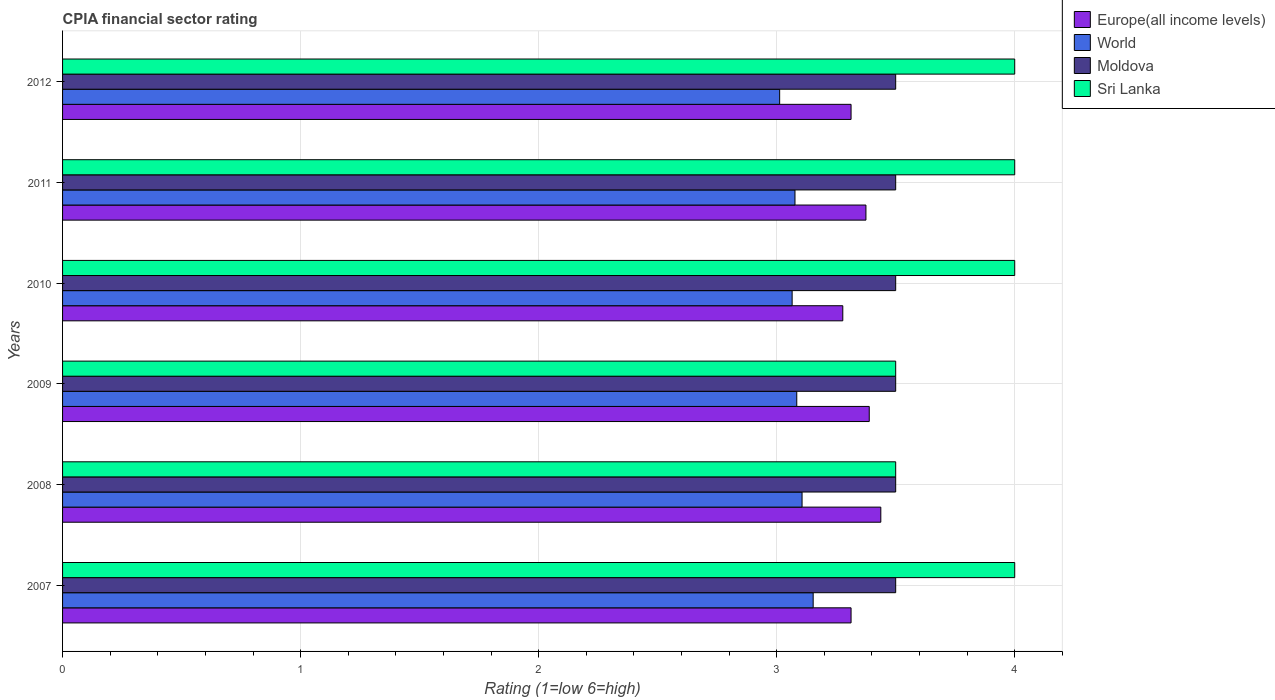How many different coloured bars are there?
Provide a short and direct response. 4. How many groups of bars are there?
Keep it short and to the point. 6. Are the number of bars on each tick of the Y-axis equal?
Offer a terse response. Yes. What is the label of the 4th group of bars from the top?
Give a very brief answer. 2009. What is the CPIA rating in Europe(all income levels) in 2010?
Your answer should be very brief. 3.28. Across all years, what is the maximum CPIA rating in Europe(all income levels)?
Give a very brief answer. 3.44. Across all years, what is the minimum CPIA rating in Europe(all income levels)?
Keep it short and to the point. 3.28. In which year was the CPIA rating in Sri Lanka maximum?
Make the answer very short. 2007. In which year was the CPIA rating in Moldova minimum?
Ensure brevity in your answer.  2007. What is the total CPIA rating in Sri Lanka in the graph?
Offer a terse response. 23. What is the difference between the CPIA rating in Moldova in 2007 and that in 2008?
Provide a succinct answer. 0. What is the difference between the CPIA rating in World in 2010 and the CPIA rating in Sri Lanka in 2011?
Offer a very short reply. -0.94. What is the average CPIA rating in Moldova per year?
Offer a very short reply. 3.5. In the year 2007, what is the difference between the CPIA rating in Sri Lanka and CPIA rating in Moldova?
Ensure brevity in your answer.  0.5. What is the ratio of the CPIA rating in Moldova in 2009 to that in 2010?
Offer a terse response. 1. Is the CPIA rating in Europe(all income levels) in 2010 less than that in 2012?
Offer a very short reply. Yes. Is the difference between the CPIA rating in Sri Lanka in 2007 and 2011 greater than the difference between the CPIA rating in Moldova in 2007 and 2011?
Offer a terse response. No. What is the difference between the highest and the lowest CPIA rating in World?
Provide a short and direct response. 0.14. Is the sum of the CPIA rating in Sri Lanka in 2007 and 2008 greater than the maximum CPIA rating in Moldova across all years?
Offer a terse response. Yes. Is it the case that in every year, the sum of the CPIA rating in Sri Lanka and CPIA rating in Moldova is greater than the sum of CPIA rating in Europe(all income levels) and CPIA rating in World?
Provide a succinct answer. No. What does the 4th bar from the top in 2011 represents?
Keep it short and to the point. Europe(all income levels). What does the 1st bar from the bottom in 2011 represents?
Offer a very short reply. Europe(all income levels). Is it the case that in every year, the sum of the CPIA rating in Moldova and CPIA rating in World is greater than the CPIA rating in Europe(all income levels)?
Your answer should be compact. Yes. What is the difference between two consecutive major ticks on the X-axis?
Give a very brief answer. 1. Does the graph contain any zero values?
Your response must be concise. No. What is the title of the graph?
Keep it short and to the point. CPIA financial sector rating. Does "Suriname" appear as one of the legend labels in the graph?
Your answer should be very brief. No. What is the label or title of the X-axis?
Provide a short and direct response. Rating (1=low 6=high). What is the label or title of the Y-axis?
Give a very brief answer. Years. What is the Rating (1=low 6=high) of Europe(all income levels) in 2007?
Offer a terse response. 3.31. What is the Rating (1=low 6=high) of World in 2007?
Keep it short and to the point. 3.15. What is the Rating (1=low 6=high) of Europe(all income levels) in 2008?
Offer a very short reply. 3.44. What is the Rating (1=low 6=high) of World in 2008?
Offer a terse response. 3.11. What is the Rating (1=low 6=high) in Moldova in 2008?
Offer a terse response. 3.5. What is the Rating (1=low 6=high) of Sri Lanka in 2008?
Make the answer very short. 3.5. What is the Rating (1=low 6=high) in Europe(all income levels) in 2009?
Offer a very short reply. 3.39. What is the Rating (1=low 6=high) of World in 2009?
Offer a very short reply. 3.08. What is the Rating (1=low 6=high) of Moldova in 2009?
Ensure brevity in your answer.  3.5. What is the Rating (1=low 6=high) in Sri Lanka in 2009?
Make the answer very short. 3.5. What is the Rating (1=low 6=high) of Europe(all income levels) in 2010?
Your answer should be compact. 3.28. What is the Rating (1=low 6=high) in World in 2010?
Keep it short and to the point. 3.06. What is the Rating (1=low 6=high) in Moldova in 2010?
Your response must be concise. 3.5. What is the Rating (1=low 6=high) in Sri Lanka in 2010?
Provide a short and direct response. 4. What is the Rating (1=low 6=high) of Europe(all income levels) in 2011?
Make the answer very short. 3.38. What is the Rating (1=low 6=high) of World in 2011?
Ensure brevity in your answer.  3.08. What is the Rating (1=low 6=high) in Moldova in 2011?
Your answer should be compact. 3.5. What is the Rating (1=low 6=high) in Europe(all income levels) in 2012?
Give a very brief answer. 3.31. What is the Rating (1=low 6=high) in World in 2012?
Ensure brevity in your answer.  3.01. What is the Rating (1=low 6=high) of Moldova in 2012?
Offer a very short reply. 3.5. Across all years, what is the maximum Rating (1=low 6=high) in Europe(all income levels)?
Ensure brevity in your answer.  3.44. Across all years, what is the maximum Rating (1=low 6=high) of World?
Give a very brief answer. 3.15. Across all years, what is the maximum Rating (1=low 6=high) in Moldova?
Offer a very short reply. 3.5. Across all years, what is the minimum Rating (1=low 6=high) in Europe(all income levels)?
Your answer should be compact. 3.28. Across all years, what is the minimum Rating (1=low 6=high) in World?
Your answer should be very brief. 3.01. Across all years, what is the minimum Rating (1=low 6=high) of Moldova?
Offer a terse response. 3.5. Across all years, what is the minimum Rating (1=low 6=high) of Sri Lanka?
Make the answer very short. 3.5. What is the total Rating (1=low 6=high) in Europe(all income levels) in the graph?
Keep it short and to the point. 20.1. What is the total Rating (1=low 6=high) of World in the graph?
Make the answer very short. 18.5. What is the total Rating (1=low 6=high) in Moldova in the graph?
Your answer should be very brief. 21. What is the total Rating (1=low 6=high) in Sri Lanka in the graph?
Provide a short and direct response. 23. What is the difference between the Rating (1=low 6=high) in Europe(all income levels) in 2007 and that in 2008?
Offer a very short reply. -0.12. What is the difference between the Rating (1=low 6=high) of World in 2007 and that in 2008?
Offer a terse response. 0.05. What is the difference between the Rating (1=low 6=high) in Moldova in 2007 and that in 2008?
Keep it short and to the point. 0. What is the difference between the Rating (1=low 6=high) in Europe(all income levels) in 2007 and that in 2009?
Make the answer very short. -0.08. What is the difference between the Rating (1=low 6=high) of World in 2007 and that in 2009?
Make the answer very short. 0.07. What is the difference between the Rating (1=low 6=high) of Sri Lanka in 2007 and that in 2009?
Give a very brief answer. 0.5. What is the difference between the Rating (1=low 6=high) of Europe(all income levels) in 2007 and that in 2010?
Give a very brief answer. 0.03. What is the difference between the Rating (1=low 6=high) of World in 2007 and that in 2010?
Ensure brevity in your answer.  0.09. What is the difference between the Rating (1=low 6=high) in Europe(all income levels) in 2007 and that in 2011?
Provide a short and direct response. -0.06. What is the difference between the Rating (1=low 6=high) of World in 2007 and that in 2011?
Provide a short and direct response. 0.08. What is the difference between the Rating (1=low 6=high) of Moldova in 2007 and that in 2011?
Your response must be concise. 0. What is the difference between the Rating (1=low 6=high) of World in 2007 and that in 2012?
Offer a terse response. 0.14. What is the difference between the Rating (1=low 6=high) of Europe(all income levels) in 2008 and that in 2009?
Your answer should be compact. 0.05. What is the difference between the Rating (1=low 6=high) in World in 2008 and that in 2009?
Provide a succinct answer. 0.02. What is the difference between the Rating (1=low 6=high) in Moldova in 2008 and that in 2009?
Offer a terse response. 0. What is the difference between the Rating (1=low 6=high) of Europe(all income levels) in 2008 and that in 2010?
Make the answer very short. 0.16. What is the difference between the Rating (1=low 6=high) of World in 2008 and that in 2010?
Offer a very short reply. 0.04. What is the difference between the Rating (1=low 6=high) of Moldova in 2008 and that in 2010?
Offer a terse response. 0. What is the difference between the Rating (1=low 6=high) of Sri Lanka in 2008 and that in 2010?
Provide a short and direct response. -0.5. What is the difference between the Rating (1=low 6=high) of Europe(all income levels) in 2008 and that in 2011?
Provide a short and direct response. 0.06. What is the difference between the Rating (1=low 6=high) of World in 2008 and that in 2011?
Offer a terse response. 0.03. What is the difference between the Rating (1=low 6=high) of Moldova in 2008 and that in 2011?
Your response must be concise. 0. What is the difference between the Rating (1=low 6=high) of Sri Lanka in 2008 and that in 2011?
Ensure brevity in your answer.  -0.5. What is the difference between the Rating (1=low 6=high) in Europe(all income levels) in 2008 and that in 2012?
Your answer should be very brief. 0.12. What is the difference between the Rating (1=low 6=high) of World in 2008 and that in 2012?
Offer a terse response. 0.09. What is the difference between the Rating (1=low 6=high) of Sri Lanka in 2008 and that in 2012?
Provide a short and direct response. -0.5. What is the difference between the Rating (1=low 6=high) in Europe(all income levels) in 2009 and that in 2010?
Keep it short and to the point. 0.11. What is the difference between the Rating (1=low 6=high) in World in 2009 and that in 2010?
Your answer should be compact. 0.02. What is the difference between the Rating (1=low 6=high) in Moldova in 2009 and that in 2010?
Your response must be concise. 0. What is the difference between the Rating (1=low 6=high) of Sri Lanka in 2009 and that in 2010?
Provide a short and direct response. -0.5. What is the difference between the Rating (1=low 6=high) of Europe(all income levels) in 2009 and that in 2011?
Your response must be concise. 0.01. What is the difference between the Rating (1=low 6=high) of World in 2009 and that in 2011?
Provide a short and direct response. 0.01. What is the difference between the Rating (1=low 6=high) in Europe(all income levels) in 2009 and that in 2012?
Offer a very short reply. 0.08. What is the difference between the Rating (1=low 6=high) of World in 2009 and that in 2012?
Offer a terse response. 0.07. What is the difference between the Rating (1=low 6=high) in Moldova in 2009 and that in 2012?
Your answer should be very brief. 0. What is the difference between the Rating (1=low 6=high) in Europe(all income levels) in 2010 and that in 2011?
Give a very brief answer. -0.1. What is the difference between the Rating (1=low 6=high) in World in 2010 and that in 2011?
Your answer should be compact. -0.01. What is the difference between the Rating (1=low 6=high) of Moldova in 2010 and that in 2011?
Your response must be concise. 0. What is the difference between the Rating (1=low 6=high) in Sri Lanka in 2010 and that in 2011?
Make the answer very short. 0. What is the difference between the Rating (1=low 6=high) in Europe(all income levels) in 2010 and that in 2012?
Offer a very short reply. -0.03. What is the difference between the Rating (1=low 6=high) in World in 2010 and that in 2012?
Provide a short and direct response. 0.05. What is the difference between the Rating (1=low 6=high) in Europe(all income levels) in 2011 and that in 2012?
Your answer should be compact. 0.06. What is the difference between the Rating (1=low 6=high) in World in 2011 and that in 2012?
Make the answer very short. 0.06. What is the difference between the Rating (1=low 6=high) of Europe(all income levels) in 2007 and the Rating (1=low 6=high) of World in 2008?
Your response must be concise. 0.21. What is the difference between the Rating (1=low 6=high) in Europe(all income levels) in 2007 and the Rating (1=low 6=high) in Moldova in 2008?
Your answer should be very brief. -0.19. What is the difference between the Rating (1=low 6=high) of Europe(all income levels) in 2007 and the Rating (1=low 6=high) of Sri Lanka in 2008?
Your answer should be very brief. -0.19. What is the difference between the Rating (1=low 6=high) in World in 2007 and the Rating (1=low 6=high) in Moldova in 2008?
Ensure brevity in your answer.  -0.35. What is the difference between the Rating (1=low 6=high) in World in 2007 and the Rating (1=low 6=high) in Sri Lanka in 2008?
Your answer should be very brief. -0.35. What is the difference between the Rating (1=low 6=high) of Europe(all income levels) in 2007 and the Rating (1=low 6=high) of World in 2009?
Offer a terse response. 0.23. What is the difference between the Rating (1=low 6=high) of Europe(all income levels) in 2007 and the Rating (1=low 6=high) of Moldova in 2009?
Your answer should be very brief. -0.19. What is the difference between the Rating (1=low 6=high) in Europe(all income levels) in 2007 and the Rating (1=low 6=high) in Sri Lanka in 2009?
Keep it short and to the point. -0.19. What is the difference between the Rating (1=low 6=high) in World in 2007 and the Rating (1=low 6=high) in Moldova in 2009?
Your response must be concise. -0.35. What is the difference between the Rating (1=low 6=high) of World in 2007 and the Rating (1=low 6=high) of Sri Lanka in 2009?
Your response must be concise. -0.35. What is the difference between the Rating (1=low 6=high) in Europe(all income levels) in 2007 and the Rating (1=low 6=high) in World in 2010?
Your answer should be compact. 0.25. What is the difference between the Rating (1=low 6=high) of Europe(all income levels) in 2007 and the Rating (1=low 6=high) of Moldova in 2010?
Provide a succinct answer. -0.19. What is the difference between the Rating (1=low 6=high) of Europe(all income levels) in 2007 and the Rating (1=low 6=high) of Sri Lanka in 2010?
Provide a succinct answer. -0.69. What is the difference between the Rating (1=low 6=high) in World in 2007 and the Rating (1=low 6=high) in Moldova in 2010?
Offer a very short reply. -0.35. What is the difference between the Rating (1=low 6=high) in World in 2007 and the Rating (1=low 6=high) in Sri Lanka in 2010?
Your answer should be compact. -0.85. What is the difference between the Rating (1=low 6=high) in Moldova in 2007 and the Rating (1=low 6=high) in Sri Lanka in 2010?
Your response must be concise. -0.5. What is the difference between the Rating (1=low 6=high) in Europe(all income levels) in 2007 and the Rating (1=low 6=high) in World in 2011?
Offer a very short reply. 0.24. What is the difference between the Rating (1=low 6=high) of Europe(all income levels) in 2007 and the Rating (1=low 6=high) of Moldova in 2011?
Keep it short and to the point. -0.19. What is the difference between the Rating (1=low 6=high) of Europe(all income levels) in 2007 and the Rating (1=low 6=high) of Sri Lanka in 2011?
Make the answer very short. -0.69. What is the difference between the Rating (1=low 6=high) in World in 2007 and the Rating (1=low 6=high) in Moldova in 2011?
Offer a terse response. -0.35. What is the difference between the Rating (1=low 6=high) in World in 2007 and the Rating (1=low 6=high) in Sri Lanka in 2011?
Your answer should be compact. -0.85. What is the difference between the Rating (1=low 6=high) of Europe(all income levels) in 2007 and the Rating (1=low 6=high) of World in 2012?
Your answer should be very brief. 0.3. What is the difference between the Rating (1=low 6=high) of Europe(all income levels) in 2007 and the Rating (1=low 6=high) of Moldova in 2012?
Keep it short and to the point. -0.19. What is the difference between the Rating (1=low 6=high) in Europe(all income levels) in 2007 and the Rating (1=low 6=high) in Sri Lanka in 2012?
Offer a terse response. -0.69. What is the difference between the Rating (1=low 6=high) of World in 2007 and the Rating (1=low 6=high) of Moldova in 2012?
Provide a short and direct response. -0.35. What is the difference between the Rating (1=low 6=high) of World in 2007 and the Rating (1=low 6=high) of Sri Lanka in 2012?
Keep it short and to the point. -0.85. What is the difference between the Rating (1=low 6=high) of Europe(all income levels) in 2008 and the Rating (1=low 6=high) of World in 2009?
Provide a short and direct response. 0.35. What is the difference between the Rating (1=low 6=high) in Europe(all income levels) in 2008 and the Rating (1=low 6=high) in Moldova in 2009?
Offer a terse response. -0.06. What is the difference between the Rating (1=low 6=high) in Europe(all income levels) in 2008 and the Rating (1=low 6=high) in Sri Lanka in 2009?
Your response must be concise. -0.06. What is the difference between the Rating (1=low 6=high) in World in 2008 and the Rating (1=low 6=high) in Moldova in 2009?
Provide a succinct answer. -0.39. What is the difference between the Rating (1=low 6=high) in World in 2008 and the Rating (1=low 6=high) in Sri Lanka in 2009?
Your answer should be very brief. -0.39. What is the difference between the Rating (1=low 6=high) in Europe(all income levels) in 2008 and the Rating (1=low 6=high) in World in 2010?
Your answer should be very brief. 0.37. What is the difference between the Rating (1=low 6=high) in Europe(all income levels) in 2008 and the Rating (1=low 6=high) in Moldova in 2010?
Your response must be concise. -0.06. What is the difference between the Rating (1=low 6=high) of Europe(all income levels) in 2008 and the Rating (1=low 6=high) of Sri Lanka in 2010?
Your answer should be compact. -0.56. What is the difference between the Rating (1=low 6=high) in World in 2008 and the Rating (1=low 6=high) in Moldova in 2010?
Your answer should be compact. -0.39. What is the difference between the Rating (1=low 6=high) of World in 2008 and the Rating (1=low 6=high) of Sri Lanka in 2010?
Keep it short and to the point. -0.89. What is the difference between the Rating (1=low 6=high) of Moldova in 2008 and the Rating (1=low 6=high) of Sri Lanka in 2010?
Keep it short and to the point. -0.5. What is the difference between the Rating (1=low 6=high) of Europe(all income levels) in 2008 and the Rating (1=low 6=high) of World in 2011?
Your answer should be very brief. 0.36. What is the difference between the Rating (1=low 6=high) in Europe(all income levels) in 2008 and the Rating (1=low 6=high) in Moldova in 2011?
Your answer should be compact. -0.06. What is the difference between the Rating (1=low 6=high) of Europe(all income levels) in 2008 and the Rating (1=low 6=high) of Sri Lanka in 2011?
Offer a terse response. -0.56. What is the difference between the Rating (1=low 6=high) in World in 2008 and the Rating (1=low 6=high) in Moldova in 2011?
Give a very brief answer. -0.39. What is the difference between the Rating (1=low 6=high) of World in 2008 and the Rating (1=low 6=high) of Sri Lanka in 2011?
Make the answer very short. -0.89. What is the difference between the Rating (1=low 6=high) in Moldova in 2008 and the Rating (1=low 6=high) in Sri Lanka in 2011?
Your response must be concise. -0.5. What is the difference between the Rating (1=low 6=high) of Europe(all income levels) in 2008 and the Rating (1=low 6=high) of World in 2012?
Provide a succinct answer. 0.42. What is the difference between the Rating (1=low 6=high) in Europe(all income levels) in 2008 and the Rating (1=low 6=high) in Moldova in 2012?
Keep it short and to the point. -0.06. What is the difference between the Rating (1=low 6=high) of Europe(all income levels) in 2008 and the Rating (1=low 6=high) of Sri Lanka in 2012?
Ensure brevity in your answer.  -0.56. What is the difference between the Rating (1=low 6=high) of World in 2008 and the Rating (1=low 6=high) of Moldova in 2012?
Make the answer very short. -0.39. What is the difference between the Rating (1=low 6=high) of World in 2008 and the Rating (1=low 6=high) of Sri Lanka in 2012?
Ensure brevity in your answer.  -0.89. What is the difference between the Rating (1=low 6=high) of Europe(all income levels) in 2009 and the Rating (1=low 6=high) of World in 2010?
Provide a succinct answer. 0.32. What is the difference between the Rating (1=low 6=high) of Europe(all income levels) in 2009 and the Rating (1=low 6=high) of Moldova in 2010?
Make the answer very short. -0.11. What is the difference between the Rating (1=low 6=high) of Europe(all income levels) in 2009 and the Rating (1=low 6=high) of Sri Lanka in 2010?
Offer a very short reply. -0.61. What is the difference between the Rating (1=low 6=high) of World in 2009 and the Rating (1=low 6=high) of Moldova in 2010?
Offer a very short reply. -0.42. What is the difference between the Rating (1=low 6=high) in World in 2009 and the Rating (1=low 6=high) in Sri Lanka in 2010?
Offer a terse response. -0.92. What is the difference between the Rating (1=low 6=high) of Moldova in 2009 and the Rating (1=low 6=high) of Sri Lanka in 2010?
Your answer should be very brief. -0.5. What is the difference between the Rating (1=low 6=high) of Europe(all income levels) in 2009 and the Rating (1=low 6=high) of World in 2011?
Ensure brevity in your answer.  0.31. What is the difference between the Rating (1=low 6=high) in Europe(all income levels) in 2009 and the Rating (1=low 6=high) in Moldova in 2011?
Your response must be concise. -0.11. What is the difference between the Rating (1=low 6=high) of Europe(all income levels) in 2009 and the Rating (1=low 6=high) of Sri Lanka in 2011?
Your answer should be compact. -0.61. What is the difference between the Rating (1=low 6=high) in World in 2009 and the Rating (1=low 6=high) in Moldova in 2011?
Give a very brief answer. -0.42. What is the difference between the Rating (1=low 6=high) of World in 2009 and the Rating (1=low 6=high) of Sri Lanka in 2011?
Offer a terse response. -0.92. What is the difference between the Rating (1=low 6=high) in Europe(all income levels) in 2009 and the Rating (1=low 6=high) in World in 2012?
Give a very brief answer. 0.38. What is the difference between the Rating (1=low 6=high) of Europe(all income levels) in 2009 and the Rating (1=low 6=high) of Moldova in 2012?
Provide a succinct answer. -0.11. What is the difference between the Rating (1=low 6=high) in Europe(all income levels) in 2009 and the Rating (1=low 6=high) in Sri Lanka in 2012?
Make the answer very short. -0.61. What is the difference between the Rating (1=low 6=high) in World in 2009 and the Rating (1=low 6=high) in Moldova in 2012?
Ensure brevity in your answer.  -0.42. What is the difference between the Rating (1=low 6=high) in World in 2009 and the Rating (1=low 6=high) in Sri Lanka in 2012?
Keep it short and to the point. -0.92. What is the difference between the Rating (1=low 6=high) of Europe(all income levels) in 2010 and the Rating (1=low 6=high) of World in 2011?
Offer a terse response. 0.2. What is the difference between the Rating (1=low 6=high) of Europe(all income levels) in 2010 and the Rating (1=low 6=high) of Moldova in 2011?
Your answer should be very brief. -0.22. What is the difference between the Rating (1=low 6=high) of Europe(all income levels) in 2010 and the Rating (1=low 6=high) of Sri Lanka in 2011?
Make the answer very short. -0.72. What is the difference between the Rating (1=low 6=high) of World in 2010 and the Rating (1=low 6=high) of Moldova in 2011?
Offer a terse response. -0.44. What is the difference between the Rating (1=low 6=high) of World in 2010 and the Rating (1=low 6=high) of Sri Lanka in 2011?
Make the answer very short. -0.94. What is the difference between the Rating (1=low 6=high) in Moldova in 2010 and the Rating (1=low 6=high) in Sri Lanka in 2011?
Offer a very short reply. -0.5. What is the difference between the Rating (1=low 6=high) of Europe(all income levels) in 2010 and the Rating (1=low 6=high) of World in 2012?
Make the answer very short. 0.27. What is the difference between the Rating (1=low 6=high) of Europe(all income levels) in 2010 and the Rating (1=low 6=high) of Moldova in 2012?
Offer a terse response. -0.22. What is the difference between the Rating (1=low 6=high) of Europe(all income levels) in 2010 and the Rating (1=low 6=high) of Sri Lanka in 2012?
Provide a short and direct response. -0.72. What is the difference between the Rating (1=low 6=high) of World in 2010 and the Rating (1=low 6=high) of Moldova in 2012?
Provide a short and direct response. -0.44. What is the difference between the Rating (1=low 6=high) in World in 2010 and the Rating (1=low 6=high) in Sri Lanka in 2012?
Give a very brief answer. -0.94. What is the difference between the Rating (1=low 6=high) in Europe(all income levels) in 2011 and the Rating (1=low 6=high) in World in 2012?
Ensure brevity in your answer.  0.36. What is the difference between the Rating (1=low 6=high) in Europe(all income levels) in 2011 and the Rating (1=low 6=high) in Moldova in 2012?
Your response must be concise. -0.12. What is the difference between the Rating (1=low 6=high) in Europe(all income levels) in 2011 and the Rating (1=low 6=high) in Sri Lanka in 2012?
Offer a very short reply. -0.62. What is the difference between the Rating (1=low 6=high) of World in 2011 and the Rating (1=low 6=high) of Moldova in 2012?
Provide a short and direct response. -0.42. What is the difference between the Rating (1=low 6=high) in World in 2011 and the Rating (1=low 6=high) in Sri Lanka in 2012?
Make the answer very short. -0.92. What is the average Rating (1=low 6=high) in Europe(all income levels) per year?
Offer a very short reply. 3.35. What is the average Rating (1=low 6=high) in World per year?
Offer a terse response. 3.08. What is the average Rating (1=low 6=high) of Moldova per year?
Make the answer very short. 3.5. What is the average Rating (1=low 6=high) in Sri Lanka per year?
Your answer should be very brief. 3.83. In the year 2007, what is the difference between the Rating (1=low 6=high) in Europe(all income levels) and Rating (1=low 6=high) in World?
Keep it short and to the point. 0.16. In the year 2007, what is the difference between the Rating (1=low 6=high) of Europe(all income levels) and Rating (1=low 6=high) of Moldova?
Give a very brief answer. -0.19. In the year 2007, what is the difference between the Rating (1=low 6=high) of Europe(all income levels) and Rating (1=low 6=high) of Sri Lanka?
Offer a very short reply. -0.69. In the year 2007, what is the difference between the Rating (1=low 6=high) in World and Rating (1=low 6=high) in Moldova?
Give a very brief answer. -0.35. In the year 2007, what is the difference between the Rating (1=low 6=high) of World and Rating (1=low 6=high) of Sri Lanka?
Your answer should be very brief. -0.85. In the year 2008, what is the difference between the Rating (1=low 6=high) of Europe(all income levels) and Rating (1=low 6=high) of World?
Provide a short and direct response. 0.33. In the year 2008, what is the difference between the Rating (1=low 6=high) of Europe(all income levels) and Rating (1=low 6=high) of Moldova?
Ensure brevity in your answer.  -0.06. In the year 2008, what is the difference between the Rating (1=low 6=high) in Europe(all income levels) and Rating (1=low 6=high) in Sri Lanka?
Ensure brevity in your answer.  -0.06. In the year 2008, what is the difference between the Rating (1=low 6=high) of World and Rating (1=low 6=high) of Moldova?
Give a very brief answer. -0.39. In the year 2008, what is the difference between the Rating (1=low 6=high) of World and Rating (1=low 6=high) of Sri Lanka?
Your answer should be very brief. -0.39. In the year 2008, what is the difference between the Rating (1=low 6=high) in Moldova and Rating (1=low 6=high) in Sri Lanka?
Offer a terse response. 0. In the year 2009, what is the difference between the Rating (1=low 6=high) of Europe(all income levels) and Rating (1=low 6=high) of World?
Give a very brief answer. 0.3. In the year 2009, what is the difference between the Rating (1=low 6=high) of Europe(all income levels) and Rating (1=low 6=high) of Moldova?
Make the answer very short. -0.11. In the year 2009, what is the difference between the Rating (1=low 6=high) in Europe(all income levels) and Rating (1=low 6=high) in Sri Lanka?
Ensure brevity in your answer.  -0.11. In the year 2009, what is the difference between the Rating (1=low 6=high) in World and Rating (1=low 6=high) in Moldova?
Ensure brevity in your answer.  -0.42. In the year 2009, what is the difference between the Rating (1=low 6=high) of World and Rating (1=low 6=high) of Sri Lanka?
Keep it short and to the point. -0.42. In the year 2010, what is the difference between the Rating (1=low 6=high) in Europe(all income levels) and Rating (1=low 6=high) in World?
Offer a very short reply. 0.21. In the year 2010, what is the difference between the Rating (1=low 6=high) in Europe(all income levels) and Rating (1=low 6=high) in Moldova?
Ensure brevity in your answer.  -0.22. In the year 2010, what is the difference between the Rating (1=low 6=high) of Europe(all income levels) and Rating (1=low 6=high) of Sri Lanka?
Offer a very short reply. -0.72. In the year 2010, what is the difference between the Rating (1=low 6=high) of World and Rating (1=low 6=high) of Moldova?
Keep it short and to the point. -0.44. In the year 2010, what is the difference between the Rating (1=low 6=high) of World and Rating (1=low 6=high) of Sri Lanka?
Your response must be concise. -0.94. In the year 2011, what is the difference between the Rating (1=low 6=high) in Europe(all income levels) and Rating (1=low 6=high) in World?
Offer a very short reply. 0.3. In the year 2011, what is the difference between the Rating (1=low 6=high) in Europe(all income levels) and Rating (1=low 6=high) in Moldova?
Provide a succinct answer. -0.12. In the year 2011, what is the difference between the Rating (1=low 6=high) in Europe(all income levels) and Rating (1=low 6=high) in Sri Lanka?
Keep it short and to the point. -0.62. In the year 2011, what is the difference between the Rating (1=low 6=high) in World and Rating (1=low 6=high) in Moldova?
Provide a short and direct response. -0.42. In the year 2011, what is the difference between the Rating (1=low 6=high) of World and Rating (1=low 6=high) of Sri Lanka?
Your response must be concise. -0.92. In the year 2012, what is the difference between the Rating (1=low 6=high) in Europe(all income levels) and Rating (1=low 6=high) in Moldova?
Provide a succinct answer. -0.19. In the year 2012, what is the difference between the Rating (1=low 6=high) of Europe(all income levels) and Rating (1=low 6=high) of Sri Lanka?
Provide a short and direct response. -0.69. In the year 2012, what is the difference between the Rating (1=low 6=high) in World and Rating (1=low 6=high) in Moldova?
Provide a succinct answer. -0.49. In the year 2012, what is the difference between the Rating (1=low 6=high) of World and Rating (1=low 6=high) of Sri Lanka?
Keep it short and to the point. -0.99. What is the ratio of the Rating (1=low 6=high) in Europe(all income levels) in 2007 to that in 2008?
Provide a succinct answer. 0.96. What is the ratio of the Rating (1=low 6=high) of Moldova in 2007 to that in 2008?
Keep it short and to the point. 1. What is the ratio of the Rating (1=low 6=high) in Sri Lanka in 2007 to that in 2008?
Your answer should be very brief. 1.14. What is the ratio of the Rating (1=low 6=high) in Europe(all income levels) in 2007 to that in 2009?
Your response must be concise. 0.98. What is the ratio of the Rating (1=low 6=high) in World in 2007 to that in 2009?
Offer a terse response. 1.02. What is the ratio of the Rating (1=low 6=high) of Sri Lanka in 2007 to that in 2009?
Give a very brief answer. 1.14. What is the ratio of the Rating (1=low 6=high) in Europe(all income levels) in 2007 to that in 2010?
Provide a succinct answer. 1.01. What is the ratio of the Rating (1=low 6=high) of World in 2007 to that in 2010?
Your answer should be very brief. 1.03. What is the ratio of the Rating (1=low 6=high) of Europe(all income levels) in 2007 to that in 2011?
Ensure brevity in your answer.  0.98. What is the ratio of the Rating (1=low 6=high) in World in 2007 to that in 2011?
Your response must be concise. 1.02. What is the ratio of the Rating (1=low 6=high) in Europe(all income levels) in 2007 to that in 2012?
Offer a terse response. 1. What is the ratio of the Rating (1=low 6=high) of World in 2007 to that in 2012?
Provide a short and direct response. 1.05. What is the ratio of the Rating (1=low 6=high) of Europe(all income levels) in 2008 to that in 2009?
Your response must be concise. 1.01. What is the ratio of the Rating (1=low 6=high) of Moldova in 2008 to that in 2009?
Make the answer very short. 1. What is the ratio of the Rating (1=low 6=high) of Europe(all income levels) in 2008 to that in 2010?
Keep it short and to the point. 1.05. What is the ratio of the Rating (1=low 6=high) in World in 2008 to that in 2010?
Ensure brevity in your answer.  1.01. What is the ratio of the Rating (1=low 6=high) in Moldova in 2008 to that in 2010?
Ensure brevity in your answer.  1. What is the ratio of the Rating (1=low 6=high) in Europe(all income levels) in 2008 to that in 2011?
Provide a succinct answer. 1.02. What is the ratio of the Rating (1=low 6=high) of World in 2008 to that in 2011?
Your answer should be very brief. 1.01. What is the ratio of the Rating (1=low 6=high) of Moldova in 2008 to that in 2011?
Give a very brief answer. 1. What is the ratio of the Rating (1=low 6=high) of Europe(all income levels) in 2008 to that in 2012?
Offer a very short reply. 1.04. What is the ratio of the Rating (1=low 6=high) in World in 2008 to that in 2012?
Ensure brevity in your answer.  1.03. What is the ratio of the Rating (1=low 6=high) in Moldova in 2008 to that in 2012?
Your response must be concise. 1. What is the ratio of the Rating (1=low 6=high) of Europe(all income levels) in 2009 to that in 2010?
Ensure brevity in your answer.  1.03. What is the ratio of the Rating (1=low 6=high) in World in 2009 to that in 2010?
Ensure brevity in your answer.  1.01. What is the ratio of the Rating (1=low 6=high) of Moldova in 2009 to that in 2011?
Your response must be concise. 1. What is the ratio of the Rating (1=low 6=high) of Sri Lanka in 2009 to that in 2011?
Make the answer very short. 0.88. What is the ratio of the Rating (1=low 6=high) in Europe(all income levels) in 2009 to that in 2012?
Your answer should be compact. 1.02. What is the ratio of the Rating (1=low 6=high) of World in 2009 to that in 2012?
Provide a succinct answer. 1.02. What is the ratio of the Rating (1=low 6=high) of Moldova in 2009 to that in 2012?
Offer a very short reply. 1. What is the ratio of the Rating (1=low 6=high) of Europe(all income levels) in 2010 to that in 2011?
Your answer should be compact. 0.97. What is the ratio of the Rating (1=low 6=high) of Sri Lanka in 2010 to that in 2011?
Your answer should be compact. 1. What is the ratio of the Rating (1=low 6=high) of World in 2010 to that in 2012?
Ensure brevity in your answer.  1.02. What is the ratio of the Rating (1=low 6=high) in Moldova in 2010 to that in 2012?
Give a very brief answer. 1. What is the ratio of the Rating (1=low 6=high) in Europe(all income levels) in 2011 to that in 2012?
Your answer should be very brief. 1.02. What is the ratio of the Rating (1=low 6=high) of World in 2011 to that in 2012?
Keep it short and to the point. 1.02. What is the ratio of the Rating (1=low 6=high) in Moldova in 2011 to that in 2012?
Provide a succinct answer. 1. What is the difference between the highest and the second highest Rating (1=low 6=high) in Europe(all income levels)?
Make the answer very short. 0.05. What is the difference between the highest and the second highest Rating (1=low 6=high) of World?
Provide a short and direct response. 0.05. What is the difference between the highest and the lowest Rating (1=low 6=high) of Europe(all income levels)?
Your answer should be very brief. 0.16. What is the difference between the highest and the lowest Rating (1=low 6=high) of World?
Keep it short and to the point. 0.14. 